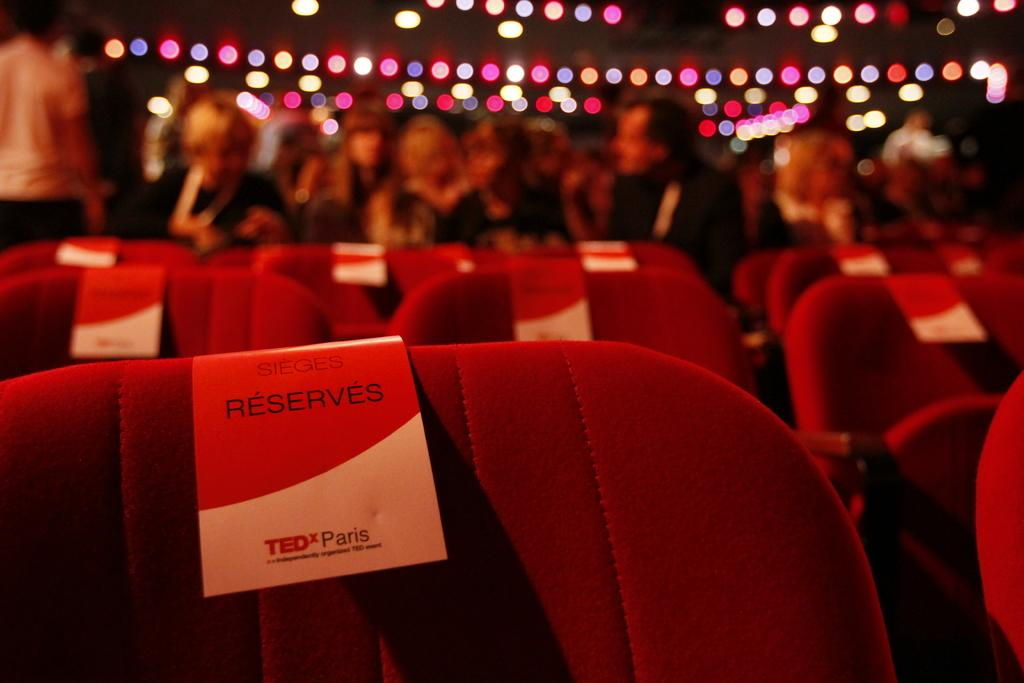What is the overall lighting condition in the image? The image is dark. What objects can be seen in the image? There are empty chairs in the image. Are there any additional items attached to the chairs? Yes, there are pamphlets attached to some chairs. What can be observed in the background of the image? There are people and lights visible in the background. How many rings are visible on the people in the background? There are no rings visible on the people in the background, as the image does not show any rings. What type of nose can be seen on the door in the image? There is no door present in the image, and therefore no nose can be seen. 